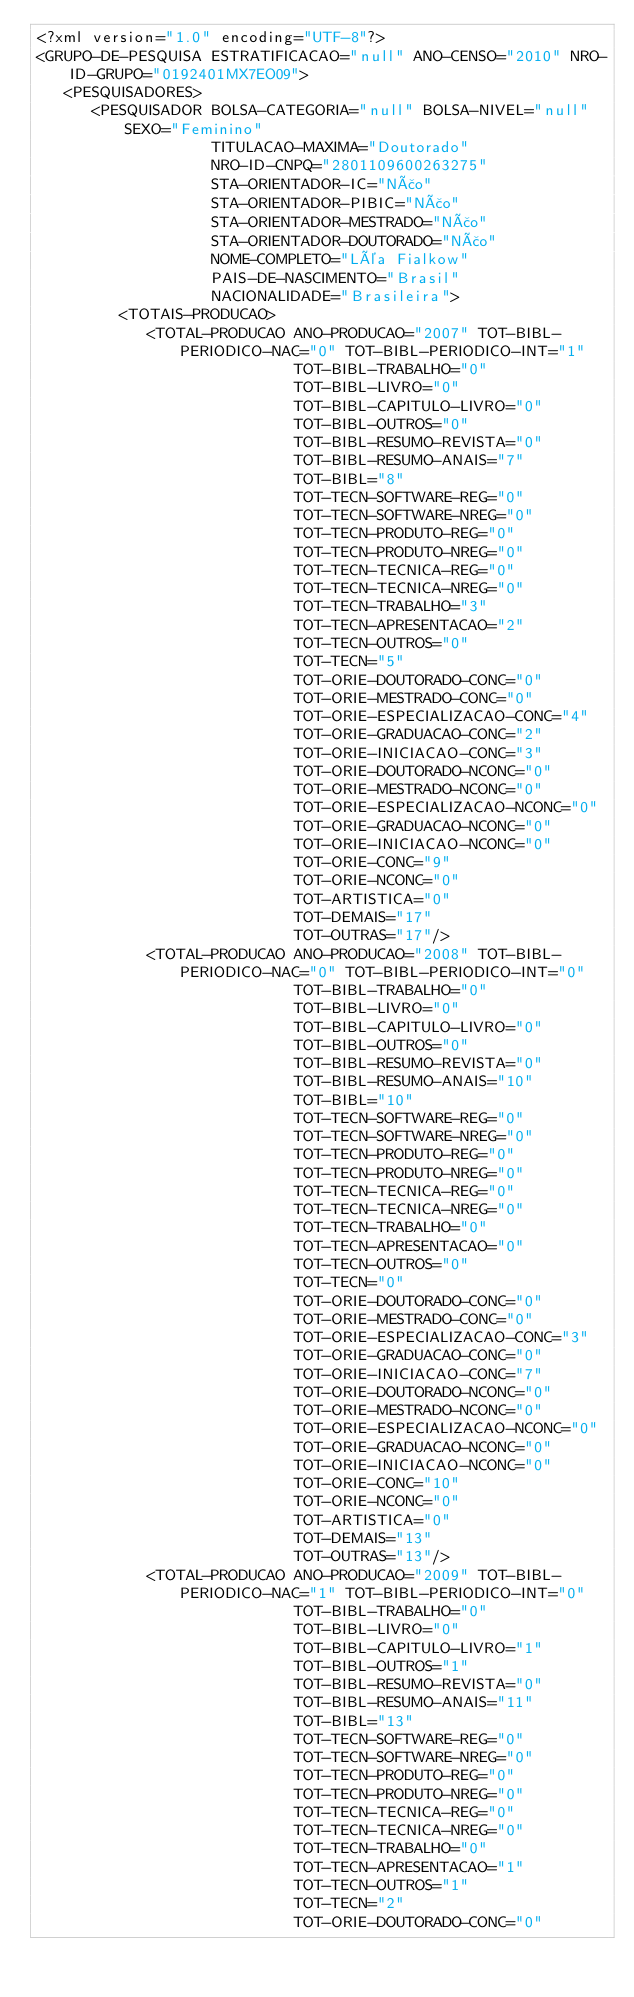<code> <loc_0><loc_0><loc_500><loc_500><_XML_><?xml version="1.0" encoding="UTF-8"?>
<GRUPO-DE-PESQUISA ESTRATIFICACAO="null" ANO-CENSO="2010" NRO-ID-GRUPO="0192401MX7EO09">
   <PESQUISADORES>
      <PESQUISADOR BOLSA-CATEGORIA="null" BOLSA-NIVEL="null" SEXO="Feminino"
                   TITULACAO-MAXIMA="Doutorado"
                   NRO-ID-CNPQ="2801109600263275"
                   STA-ORIENTADOR-IC="Não"
                   STA-ORIENTADOR-PIBIC="Não"
                   STA-ORIENTADOR-MESTRADO="Não"
                   STA-ORIENTADOR-DOUTORADO="Não"
                   NOME-COMPLETO="Léa Fialkow"
                   PAIS-DE-NASCIMENTO="Brasil"
                   NACIONALIDADE="Brasileira">
         <TOTAIS-PRODUCAO>
            <TOTAL-PRODUCAO ANO-PRODUCAO="2007" TOT-BIBL-PERIODICO-NAC="0" TOT-BIBL-PERIODICO-INT="1"
                            TOT-BIBL-TRABALHO="0"
                            TOT-BIBL-LIVRO="0"
                            TOT-BIBL-CAPITULO-LIVRO="0"
                            TOT-BIBL-OUTROS="0"
                            TOT-BIBL-RESUMO-REVISTA="0"
                            TOT-BIBL-RESUMO-ANAIS="7"
                            TOT-BIBL="8"
                            TOT-TECN-SOFTWARE-REG="0"
                            TOT-TECN-SOFTWARE-NREG="0"
                            TOT-TECN-PRODUTO-REG="0"
                            TOT-TECN-PRODUTO-NREG="0"
                            TOT-TECN-TECNICA-REG="0"
                            TOT-TECN-TECNICA-NREG="0"
                            TOT-TECN-TRABALHO="3"
                            TOT-TECN-APRESENTACAO="2"
                            TOT-TECN-OUTROS="0"
                            TOT-TECN="5"
                            TOT-ORIE-DOUTORADO-CONC="0"
                            TOT-ORIE-MESTRADO-CONC="0"
                            TOT-ORIE-ESPECIALIZACAO-CONC="4"
                            TOT-ORIE-GRADUACAO-CONC="2"
                            TOT-ORIE-INICIACAO-CONC="3"
                            TOT-ORIE-DOUTORADO-NCONC="0"
                            TOT-ORIE-MESTRADO-NCONC="0"
                            TOT-ORIE-ESPECIALIZACAO-NCONC="0"
                            TOT-ORIE-GRADUACAO-NCONC="0"
                            TOT-ORIE-INICIACAO-NCONC="0"
                            TOT-ORIE-CONC="9"
                            TOT-ORIE-NCONC="0"
                            TOT-ARTISTICA="0"
                            TOT-DEMAIS="17"
                            TOT-OUTRAS="17"/>
            <TOTAL-PRODUCAO ANO-PRODUCAO="2008" TOT-BIBL-PERIODICO-NAC="0" TOT-BIBL-PERIODICO-INT="0"
                            TOT-BIBL-TRABALHO="0"
                            TOT-BIBL-LIVRO="0"
                            TOT-BIBL-CAPITULO-LIVRO="0"
                            TOT-BIBL-OUTROS="0"
                            TOT-BIBL-RESUMO-REVISTA="0"
                            TOT-BIBL-RESUMO-ANAIS="10"
                            TOT-BIBL="10"
                            TOT-TECN-SOFTWARE-REG="0"
                            TOT-TECN-SOFTWARE-NREG="0"
                            TOT-TECN-PRODUTO-REG="0"
                            TOT-TECN-PRODUTO-NREG="0"
                            TOT-TECN-TECNICA-REG="0"
                            TOT-TECN-TECNICA-NREG="0"
                            TOT-TECN-TRABALHO="0"
                            TOT-TECN-APRESENTACAO="0"
                            TOT-TECN-OUTROS="0"
                            TOT-TECN="0"
                            TOT-ORIE-DOUTORADO-CONC="0"
                            TOT-ORIE-MESTRADO-CONC="0"
                            TOT-ORIE-ESPECIALIZACAO-CONC="3"
                            TOT-ORIE-GRADUACAO-CONC="0"
                            TOT-ORIE-INICIACAO-CONC="7"
                            TOT-ORIE-DOUTORADO-NCONC="0"
                            TOT-ORIE-MESTRADO-NCONC="0"
                            TOT-ORIE-ESPECIALIZACAO-NCONC="0"
                            TOT-ORIE-GRADUACAO-NCONC="0"
                            TOT-ORIE-INICIACAO-NCONC="0"
                            TOT-ORIE-CONC="10"
                            TOT-ORIE-NCONC="0"
                            TOT-ARTISTICA="0"
                            TOT-DEMAIS="13"
                            TOT-OUTRAS="13"/>
            <TOTAL-PRODUCAO ANO-PRODUCAO="2009" TOT-BIBL-PERIODICO-NAC="1" TOT-BIBL-PERIODICO-INT="0"
                            TOT-BIBL-TRABALHO="0"
                            TOT-BIBL-LIVRO="0"
                            TOT-BIBL-CAPITULO-LIVRO="1"
                            TOT-BIBL-OUTROS="1"
                            TOT-BIBL-RESUMO-REVISTA="0"
                            TOT-BIBL-RESUMO-ANAIS="11"
                            TOT-BIBL="13"
                            TOT-TECN-SOFTWARE-REG="0"
                            TOT-TECN-SOFTWARE-NREG="0"
                            TOT-TECN-PRODUTO-REG="0"
                            TOT-TECN-PRODUTO-NREG="0"
                            TOT-TECN-TECNICA-REG="0"
                            TOT-TECN-TECNICA-NREG="0"
                            TOT-TECN-TRABALHO="0"
                            TOT-TECN-APRESENTACAO="1"
                            TOT-TECN-OUTROS="1"
                            TOT-TECN="2"
                            TOT-ORIE-DOUTORADO-CONC="0"</code> 